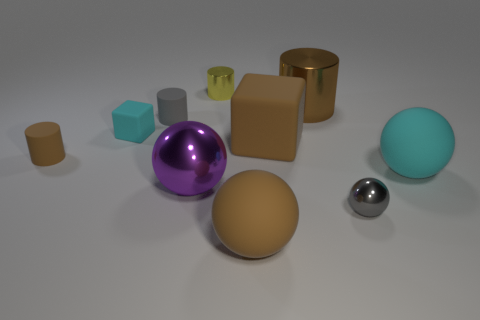Are the tiny cylinder to the left of the gray rubber cylinder and the cyan thing that is behind the large cyan rubber ball made of the same material?
Your answer should be very brief. Yes. Are there an equal number of cyan spheres behind the small cyan object and cyan rubber objects in front of the small yellow cylinder?
Offer a terse response. No. There is a block in front of the tiny matte block; what is it made of?
Offer a very short reply. Rubber. Is there anything else that has the same size as the purple object?
Your answer should be compact. Yes. Are there fewer tiny red matte objects than big brown cylinders?
Your answer should be compact. Yes. There is a shiny object that is both in front of the gray matte object and left of the small gray sphere; what is its shape?
Offer a terse response. Sphere. What number of small cyan matte objects are there?
Make the answer very short. 1. There is a small gray object right of the brown thing in front of the tiny rubber cylinder that is in front of the small cyan rubber block; what is it made of?
Your answer should be very brief. Metal. What number of balls are behind the gray thing in front of the small cyan cube?
Make the answer very short. 2. The other tiny metallic thing that is the same shape as the brown shiny object is what color?
Offer a terse response. Yellow. 